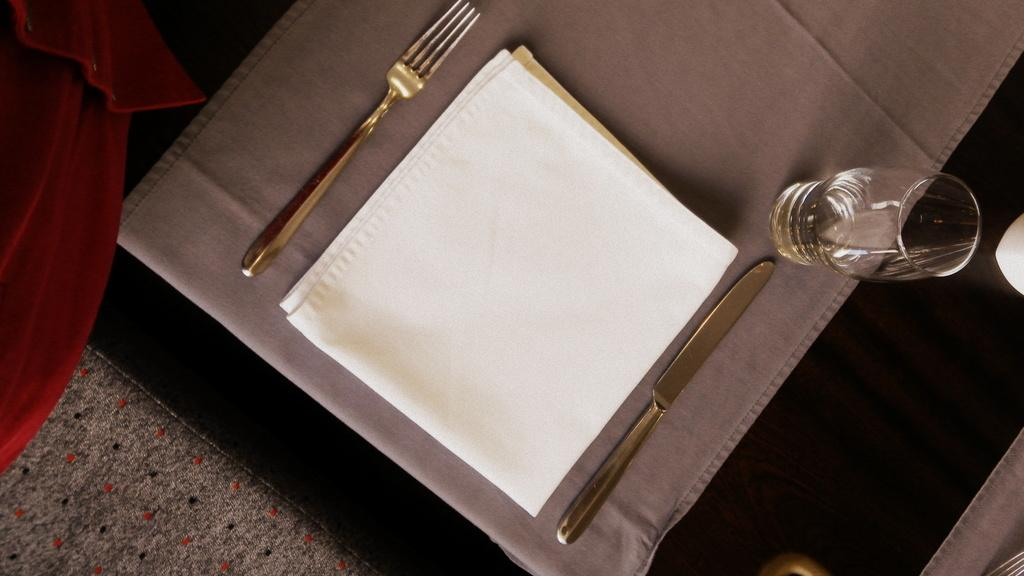What items in the image might be used for cleaning or wiping? There are napkins in the image that might be used for cleaning or wiping. What utensils are visible in the image? There is a fork and a knife visible in the image. What type of glass is present in the image? There is a wine glass in the image. What color is the cloth in the image? The cloth in the image is black. What type of flooring is visible in the image? There is a carpet in the image. What type of paint is being used on the coat in the image? There is no coat or paint present in the image. Where is the lunchroom located in the image? There is no lunchroom present in the image. 